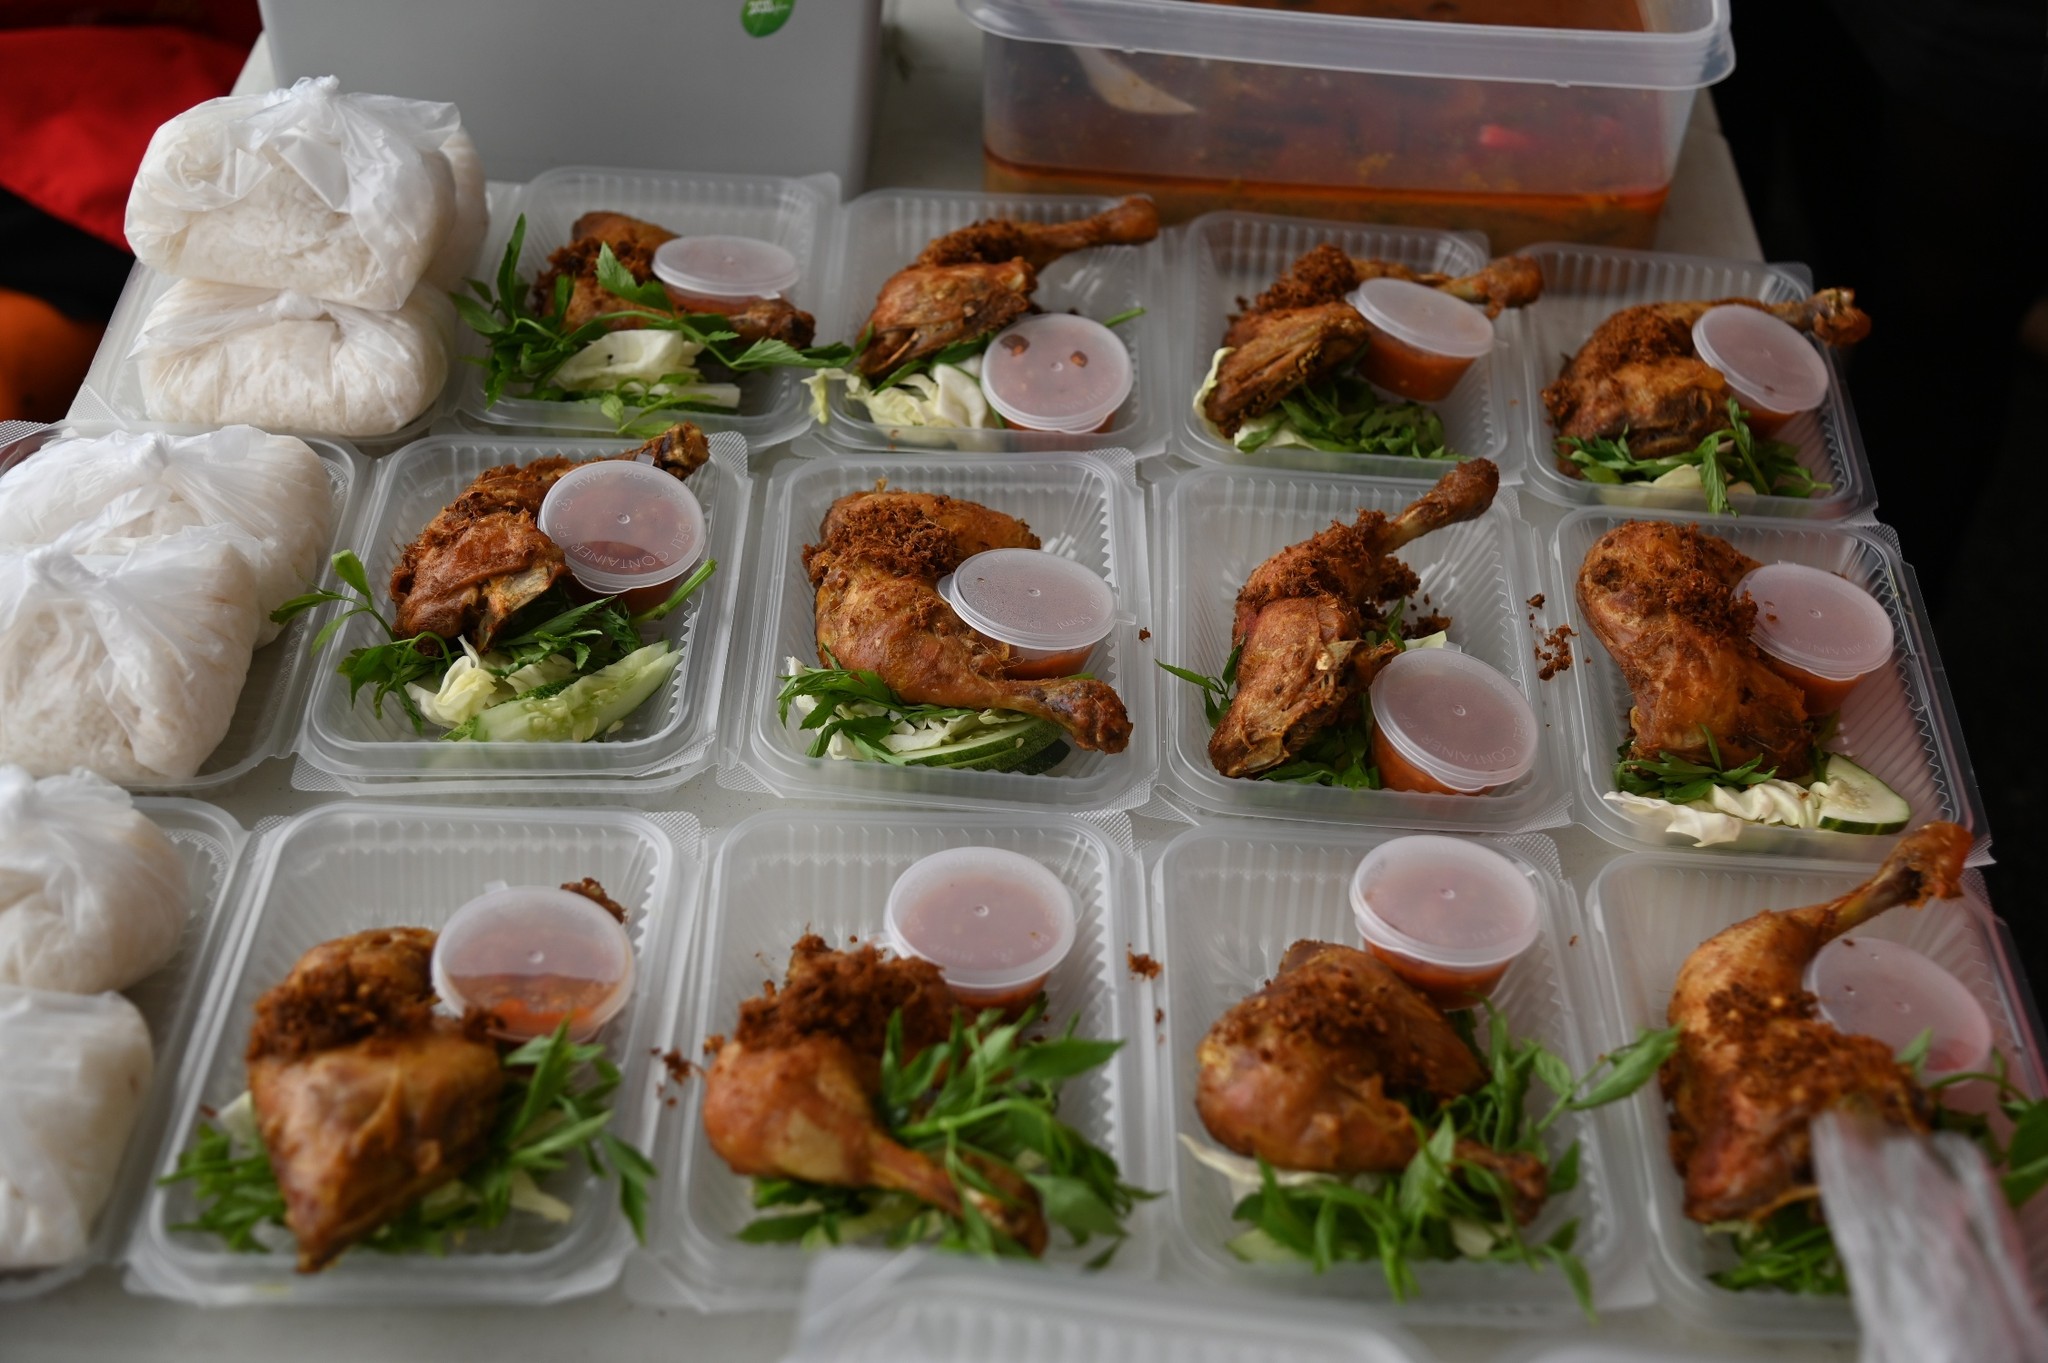Analyze the image in a comprehensive and detailed manner. The image showcases a meal preparation setup that seems to be for a catering or bulk meal distribution scenario. On the table, there are several clear plastic containers, each neatly filled with a meal that includes a golden-brown fried chicken leg on a bed of fresh greens, possibly arugula or mixed salad leaves, accompanied by a small container of sauce potentially for dressing or dipping. The chicken’s crispy appearance suggests a well-prepared, possibly seasoned coating ideal for retaining moisture and flavor. Alongside the meals, there are bags of what appears to be sticky rice, a common accompaniment that complements the savory flavor of the chicken with its mild, starchy taste. A large plastic container visible on the right possibly contains more fried chicken pieces, suggesting ongoing meal preparation. Overall, the setting underlines efficient, clean food preparation focused on delivering a consistent, enjoyable dining experience. 